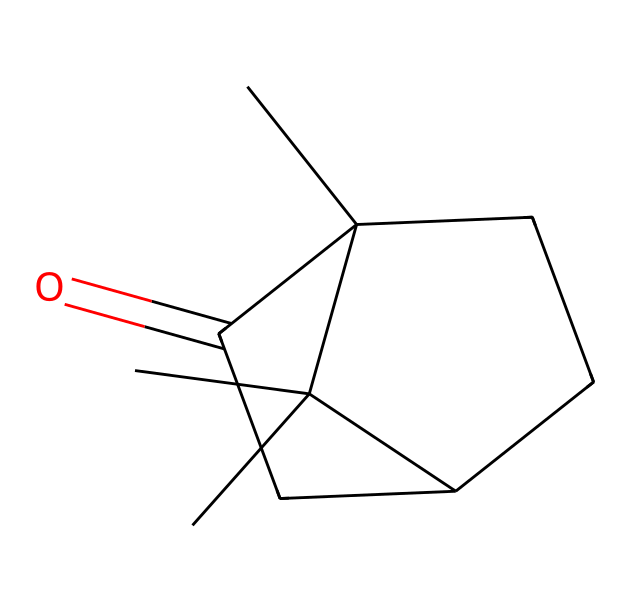What is the name of this chemical? The SMILES representation corresponds to camphor, which is a specific type of ketone.
Answer: camphor How many carbon atoms are in camphor? By examining the SMILES representation, we can count the carbon atoms present in the structure. There are 10 carbon atoms in total.
Answer: 10 What type of functional group is present in this chemical? The presence of the carbonyl group, indicated by the "C(=O)" part of the SMILES, identifies it as a ketone.
Answer: ketone How many rings are present in the camphor structure? Looking at the arrangement of atoms in the SMILES, there are two cyclic (ring) structures formed in camphor.
Answer: 2 What is the degree of saturation of camphor? The degree of saturation can be calculated by considering the number of rings and double bonds. Camphor contains two rings and one double bond (the carbonyl), leading to a degree of saturation of 4.
Answer: 4 What effect does the ketone group have on the smell of camphor? The carbonyl group in the ketone structure is responsible for the characteristic strong, aromatic odor associated with camphor.
Answer: strong aroma 